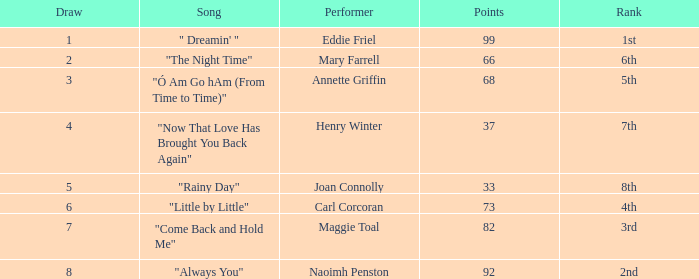What is the average number of points when the ranking is 7th and the draw is less than 4? None. 